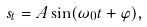<formula> <loc_0><loc_0><loc_500><loc_500>s _ { t } = A \sin ( \omega _ { 0 } t + \varphi ) ,</formula> 